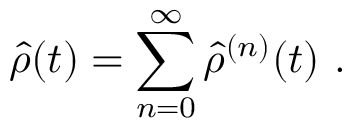<formula> <loc_0><loc_0><loc_500><loc_500>\hat { \rho } ( t ) = \sum _ { n = 0 } ^ { \infty } \hat { \rho } ^ { ( n ) } ( t ) .</formula> 